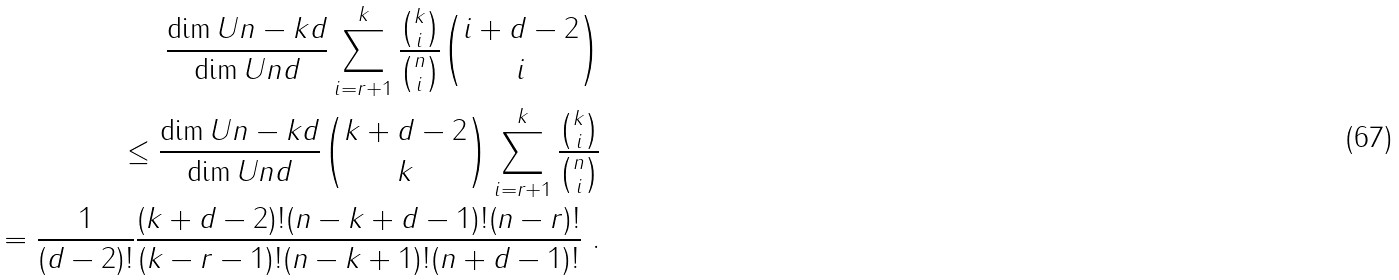Convert formula to latex. <formula><loc_0><loc_0><loc_500><loc_500>\frac { \dim U { n - k } { d } } { \dim U { n } { d } } \sum _ { i = r + 1 } ^ { k } \frac { \binom { k } { i } } { \binom { n } { i } } \binom { i + d - 2 } { i } \\ \leq \frac { \dim U { n - k } { d } } { \dim U { n } { d } } \binom { k + d - 2 } { k } \sum _ { i = r + 1 } ^ { k } \frac { \binom { k } { i } } { \binom { n } { i } } \\ = \frac { 1 } { ( d - 2 ) ! } \frac { ( k + d - 2 ) ! ( n - k + d - 1 ) ! ( n - r ) ! } { ( k - r - 1 ) ! ( n - k + 1 ) ! ( n + d - 1 ) ! } \ .</formula> 